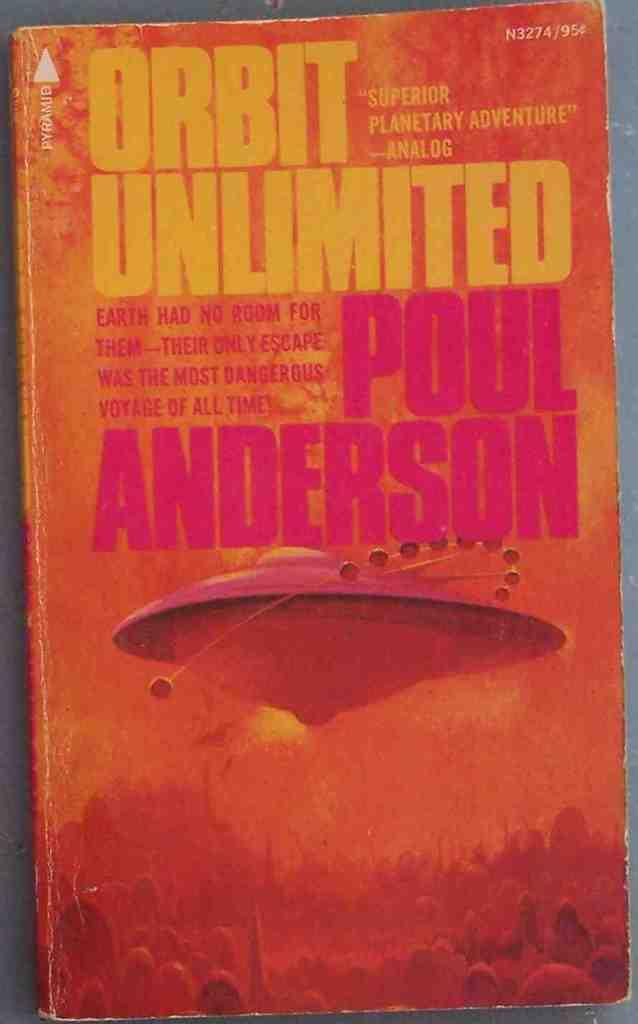<image>
Offer a succinct explanation of the picture presented. The book here is called Orbit Unlimited written by Poul Anderson 